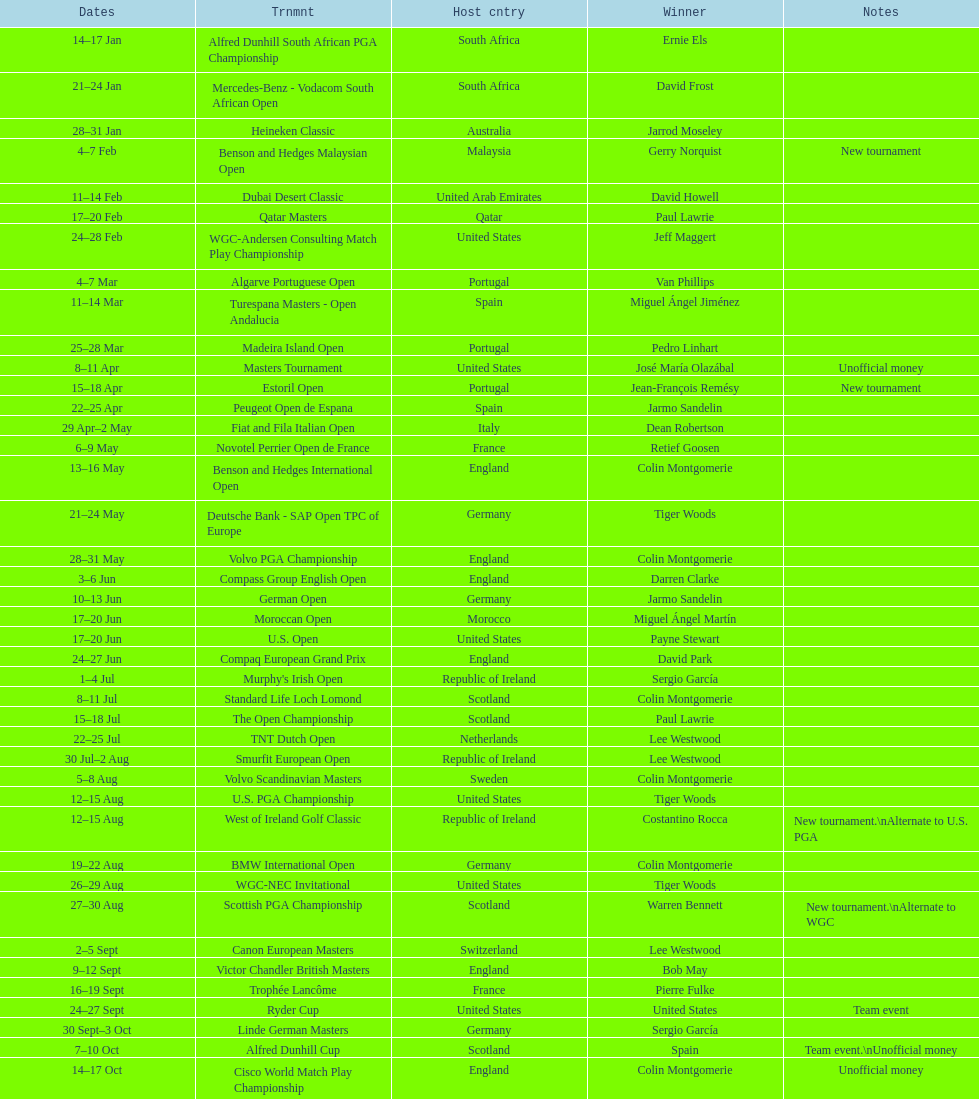Does any country have more than 5 winners? Yes. 